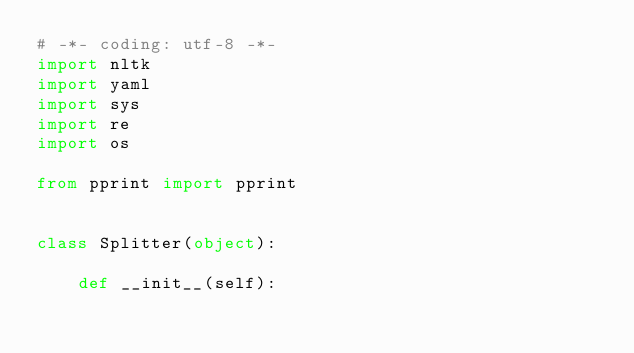<code> <loc_0><loc_0><loc_500><loc_500><_Python_># -*- coding: utf-8 -*-
import nltk    
import yaml     
import sys     
import re      
import os       

from pprint import pprint


class Splitter(object):
  
    def __init__(self):      
        </code> 